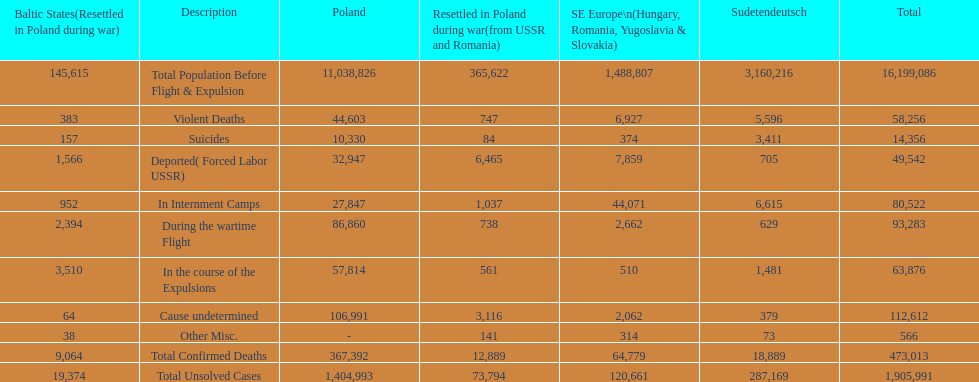Which region had the least total of unsolved cases? Baltic States(Resettled in Poland during war). 